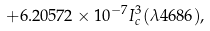Convert formula to latex. <formula><loc_0><loc_0><loc_500><loc_500>+ 6 . 2 0 5 7 2 \times 1 0 ^ { - 7 } I _ { c } ^ { 3 } ( \lambda 4 6 8 6 ) ,</formula> 